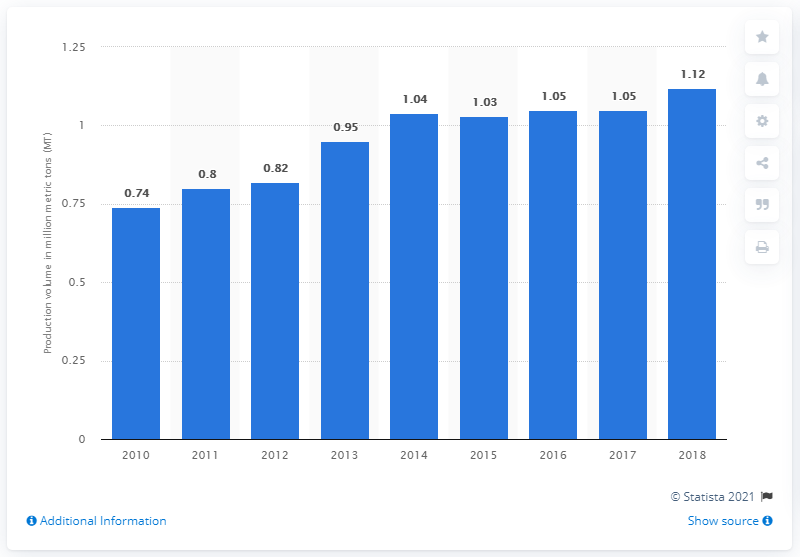Draw attention to some important aspects in this diagram. In 2018, the production of chicken meat in Egypt was 1.12 million metric tons. In 2010, Egypt's chicken meat production was approximately 0.74 million tons. 